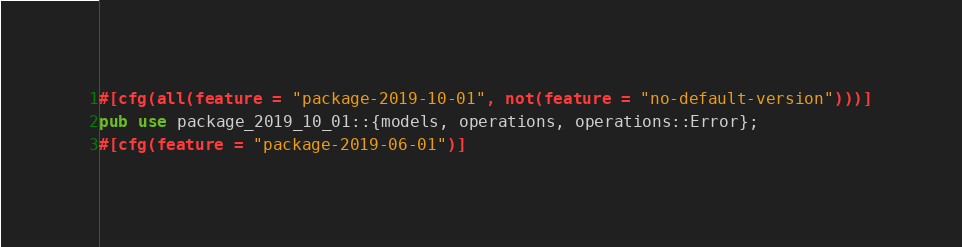Convert code to text. <code><loc_0><loc_0><loc_500><loc_500><_Rust_>#[cfg(all(feature = "package-2019-10-01", not(feature = "no-default-version")))]
pub use package_2019_10_01::{models, operations, operations::Error};
#[cfg(feature = "package-2019-06-01")]</code> 